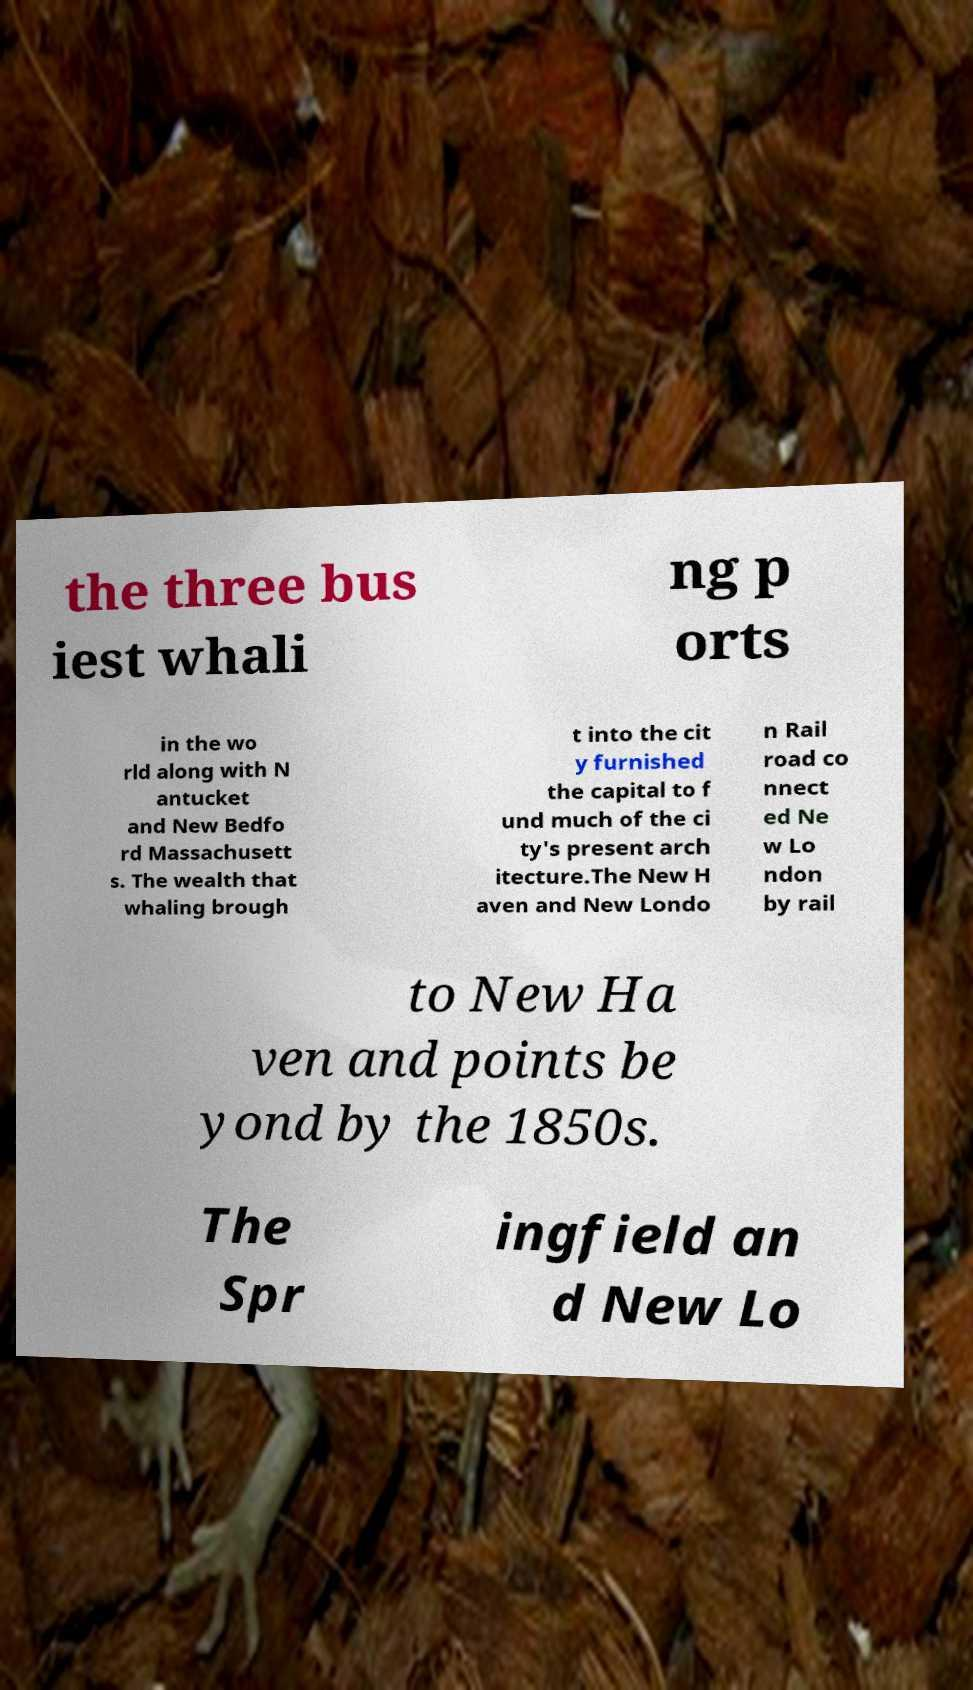What messages or text are displayed in this image? I need them in a readable, typed format. the three bus iest whali ng p orts in the wo rld along with N antucket and New Bedfo rd Massachusett s. The wealth that whaling brough t into the cit y furnished the capital to f und much of the ci ty's present arch itecture.The New H aven and New Londo n Rail road co nnect ed Ne w Lo ndon by rail to New Ha ven and points be yond by the 1850s. The Spr ingfield an d New Lo 